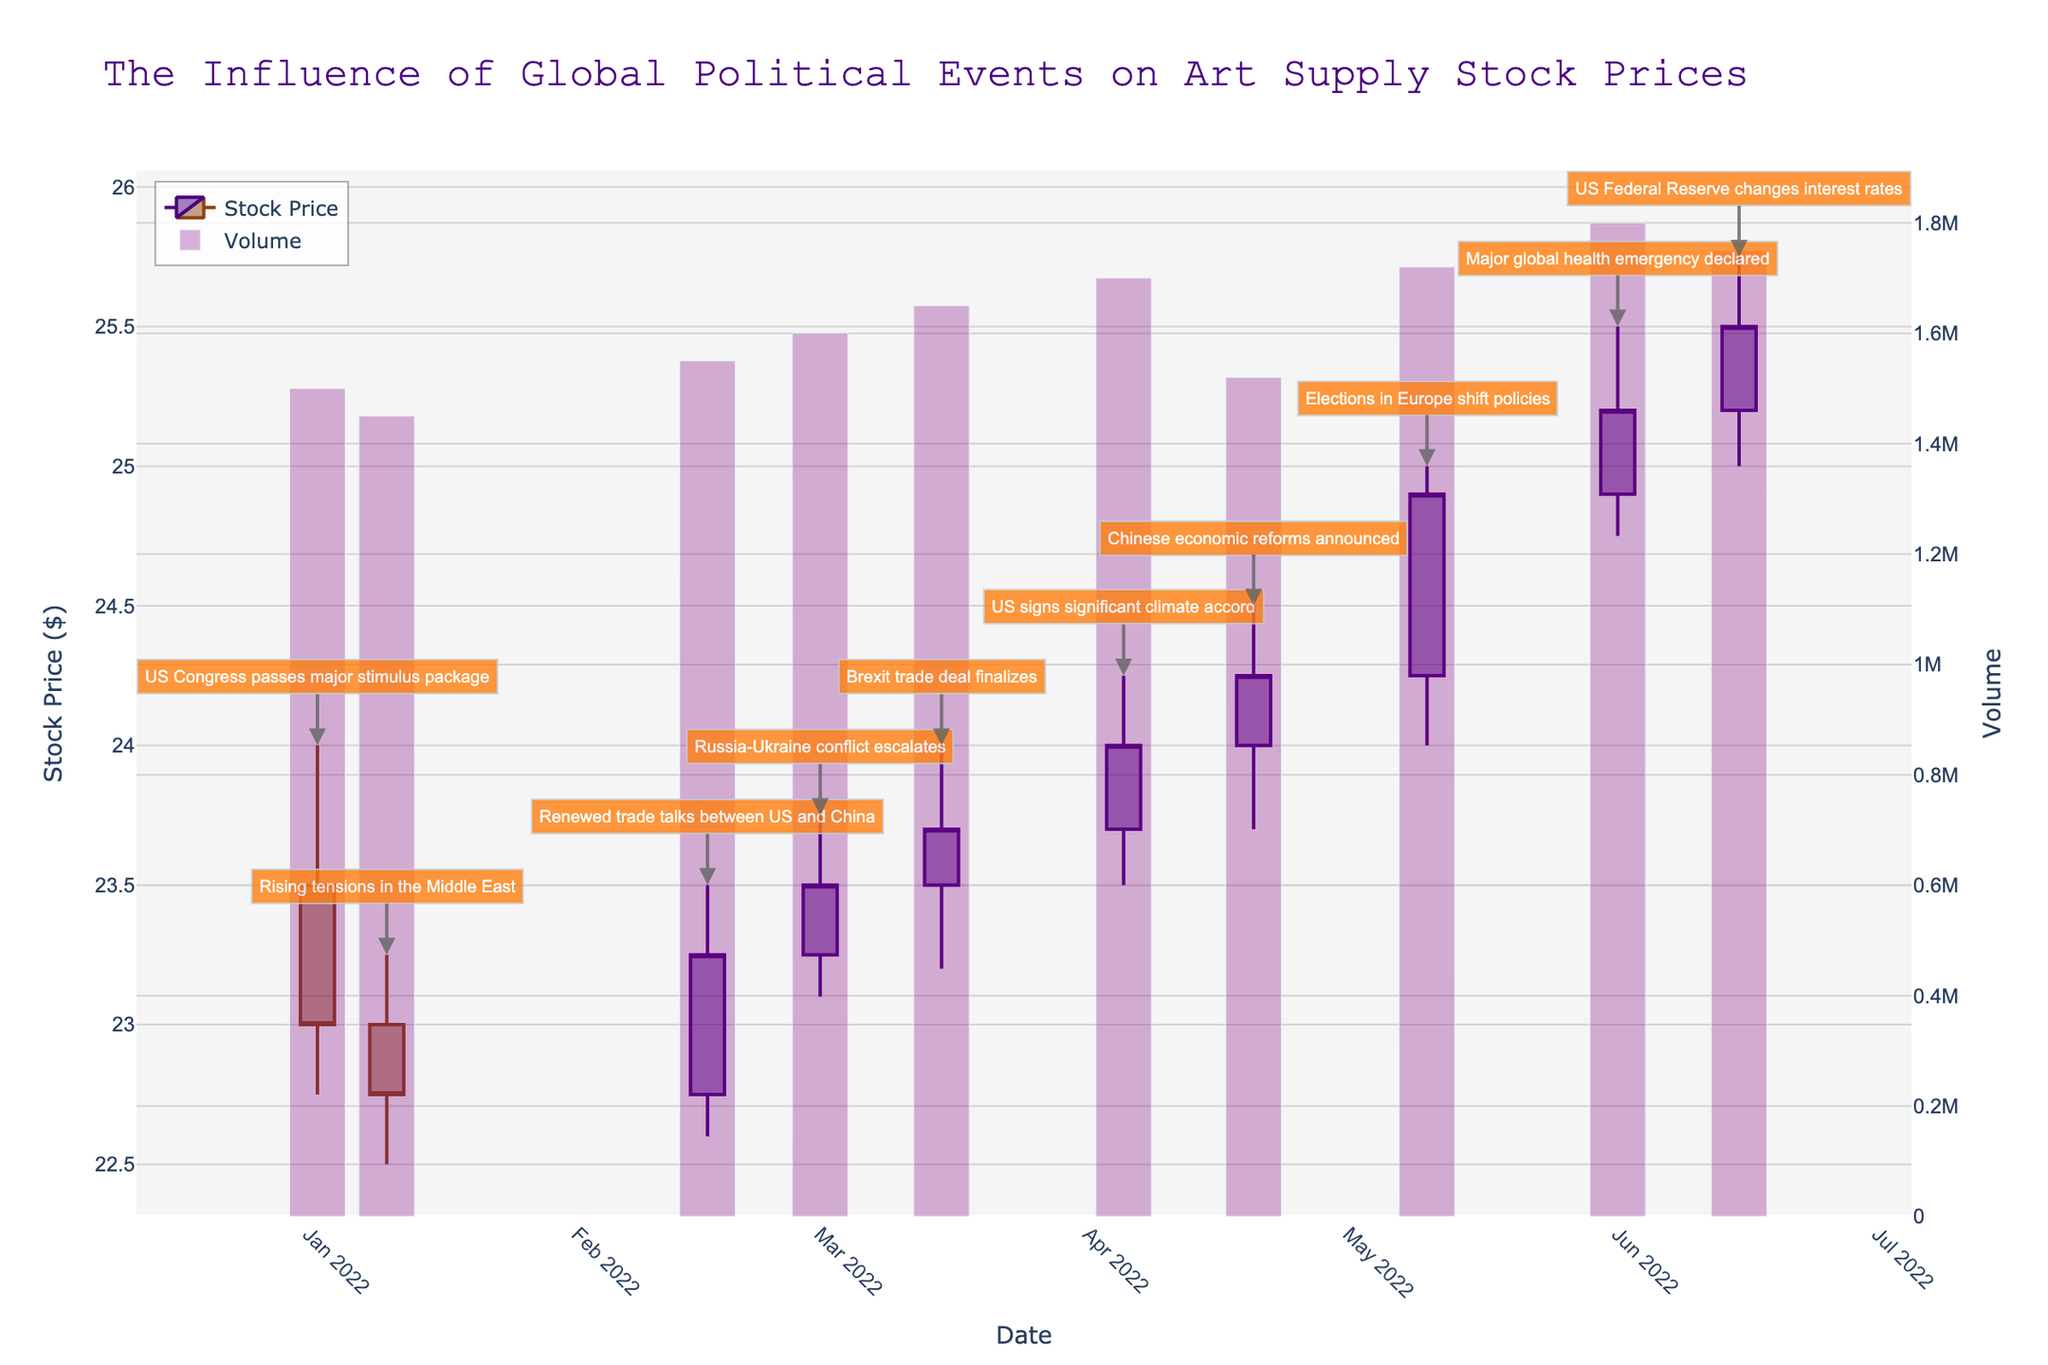What is the title of the plot? The title of the plot is shown prominently at the top center of the figure.
Answer: The Influence of Global Political Events on Art Supply Stock Prices When did the stock price reach its highest point, and what was the event? By observing the highest points in the candlestick plot and noting the corresponding dates and events, we see the highest point is on 2022-06-01 during the Major global health emergency declared.
Answer: 2022-06-01, Major global health emergency declared How did the US Congress passing a major stimulus package on 2022-01-02 affect the stock price? By observing the candlestick on 2022-01-02, the stock opened at 23.50, reached a high of 24.00, a low of 22.75, and closed at 23.00. This indicates a fairly stable movement with slight fluctuations.
Answer: The stock closed slightly lower than it opened What trend do you observe in the stock prices from 2022-03-01 to 2022-06-15? Observing the candlestick heights and closing values from 2022-03-01 to 2022-06-15, there appears to be an overall upward trend, with the stock consistently closing higher.
Answer: Upward trend Which event corresponds to the highest trading volume, and what was its value? By checking the highest bar in the volume trace and matching it with the date and corresponding event, we see the highest volume on 2022-06-01 connected to a major global health emergency declaration.
Answer: Major global health emergency declared, 1800000 Compare the stock price movement before and after US Federal Reserve changes interest rates on 2022-06-15. What do you observe? By comparing the candlesticks just before and after 2022-06-15, we notice that the price continued to increase post the event, suggesting positive stock movement.
Answer: Price increase On which date did the stock price have its lowest closing value, and what was the event? By identifying the lowest point in the "Close" column and noting the corresponding date and event, we find the lowest closing value on 2022-01-10 during rising tensions in the Middle East.
Answer: 2022-01-10, Rising tensions in the Middle East What is the range of stock prices on 2022-03-15, and what event occurred on that date? By observing the high and low prices for the candlestick on 2022-03-15, we see that it ranges from 24.00 to 23.20 during the Brexit trade deal finalizes event.
Answer: 24.00 to 23.20, Brexit trade deal finalizes How did the stock price react to renewed trade talks between the US and China on 2022-02-16? By examining the candlestick for 2022-02-16, the stock opened at 22.75, reached a high of 23.50, a low of 22.60, and closed at 23.25, indicating a positive movement and higher close.
Answer: Positive reaction, higher close 